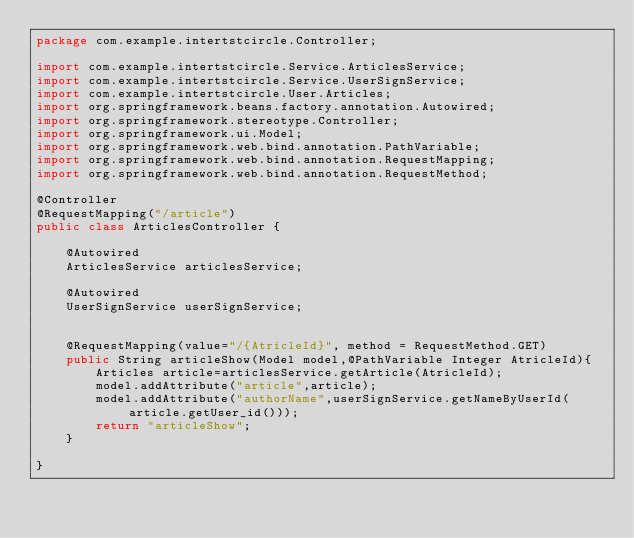Convert code to text. <code><loc_0><loc_0><loc_500><loc_500><_Java_>package com.example.intertstcircle.Controller;

import com.example.intertstcircle.Service.ArticlesService;
import com.example.intertstcircle.Service.UserSignService;
import com.example.intertstcircle.User.Articles;
import org.springframework.beans.factory.annotation.Autowired;
import org.springframework.stereotype.Controller;
import org.springframework.ui.Model;
import org.springframework.web.bind.annotation.PathVariable;
import org.springframework.web.bind.annotation.RequestMapping;
import org.springframework.web.bind.annotation.RequestMethod;

@Controller
@RequestMapping("/article")
public class ArticlesController {

    @Autowired
    ArticlesService articlesService;

    @Autowired
    UserSignService userSignService;


    @RequestMapping(value="/{AtricleId}", method = RequestMethod.GET)
    public String articleShow(Model model,@PathVariable Integer AtricleId){
        Articles article=articlesService.getArticle(AtricleId);
        model.addAttribute("article",article);
        model.addAttribute("authorName",userSignService.getNameByUserId(article.getUser_id()));
        return "articleShow";
    }

}
</code> 